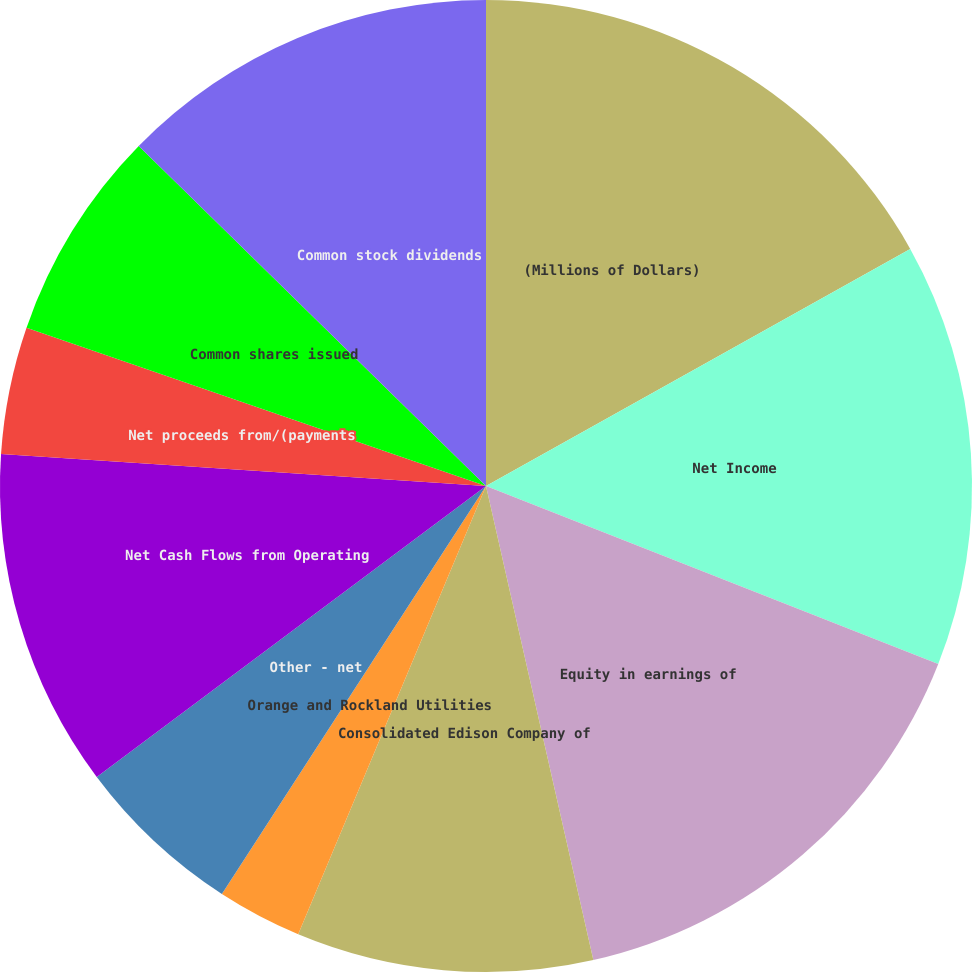Convert chart. <chart><loc_0><loc_0><loc_500><loc_500><pie_chart><fcel>(Millions of Dollars)<fcel>Net Income<fcel>Equity in earnings of<fcel>Consolidated Edison Company of<fcel>Orange and Rockland Utilities<fcel>Other - net<fcel>Net Cash Flows from Operating<fcel>Net proceeds from/(payments<fcel>Common shares issued<fcel>Common stock dividends<nl><fcel>16.89%<fcel>14.08%<fcel>15.49%<fcel>9.86%<fcel>2.83%<fcel>5.64%<fcel>11.27%<fcel>4.23%<fcel>7.05%<fcel>12.67%<nl></chart> 